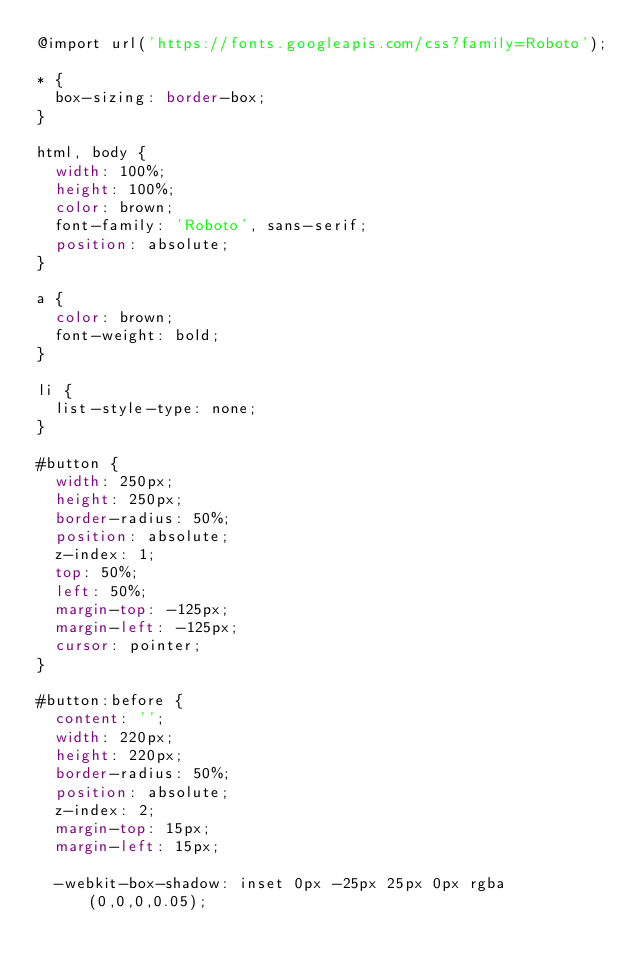Convert code to text. <code><loc_0><loc_0><loc_500><loc_500><_CSS_>@import url('https://fonts.googleapis.com/css?family=Roboto');

* {
  box-sizing: border-box;
}

html, body {
  width: 100%;
  height: 100%;
  color: brown;
  font-family: 'Roboto', sans-serif;
  position: absolute;
}

a {
  color: brown;
  font-weight: bold;
}

li {
  list-style-type: none;
}

#button {
  width: 250px;
  height: 250px;
  border-radius: 50%;
  position: absolute;
  z-index: 1;
  top: 50%;
  left: 50%;
  margin-top: -125px;
  margin-left: -125px;
  cursor: pointer;
}

#button:before {
  content: '';
  width: 220px;
  height: 220px;
  border-radius: 50%;
  position: absolute;
  z-index: 2;
  margin-top: 15px;
  margin-left: 15px;

  -webkit-box-shadow: inset 0px -25px 25px 0px rgba(0,0,0,0.05);</code> 